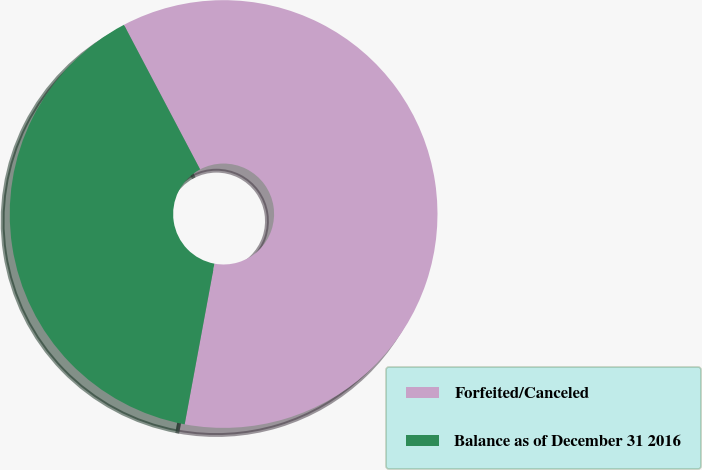Convert chart. <chart><loc_0><loc_0><loc_500><loc_500><pie_chart><fcel>Forfeited/Canceled<fcel>Balance as of December 31 2016<nl><fcel>60.63%<fcel>39.37%<nl></chart> 